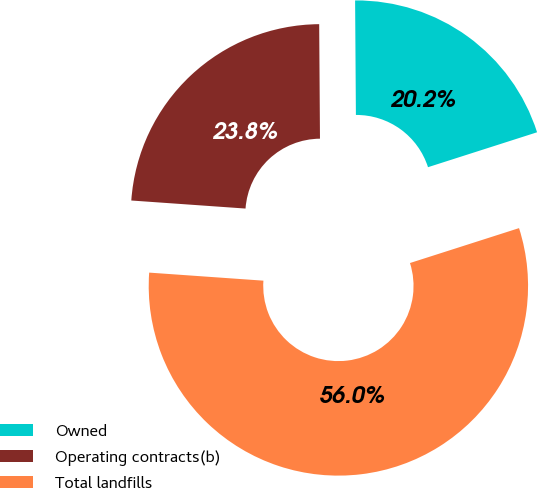Convert chart to OTSL. <chart><loc_0><loc_0><loc_500><loc_500><pie_chart><fcel>Owned<fcel>Operating contracts(b)<fcel>Total landfills<nl><fcel>20.18%<fcel>23.77%<fcel>56.05%<nl></chart> 